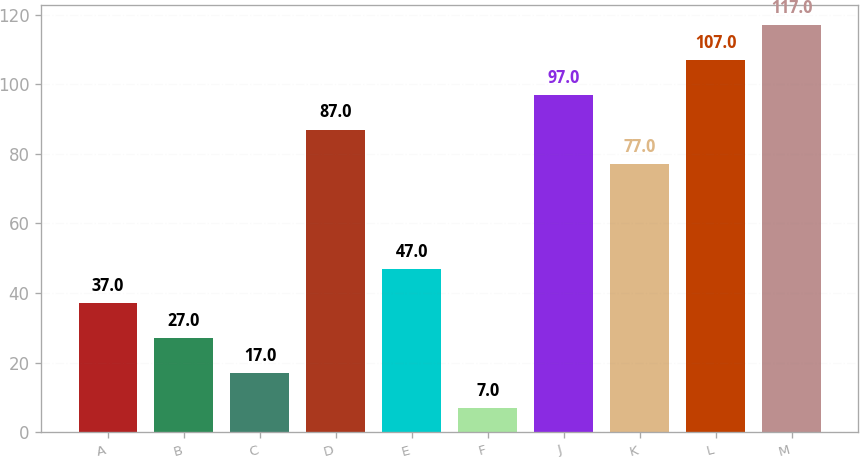Convert chart to OTSL. <chart><loc_0><loc_0><loc_500><loc_500><bar_chart><fcel>A<fcel>B<fcel>C<fcel>D<fcel>E<fcel>F<fcel>J<fcel>K<fcel>L<fcel>M<nl><fcel>37<fcel>27<fcel>17<fcel>87<fcel>47<fcel>7<fcel>97<fcel>77<fcel>107<fcel>117<nl></chart> 